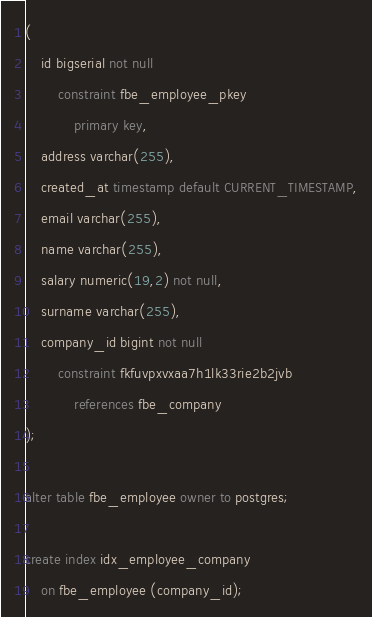<code> <loc_0><loc_0><loc_500><loc_500><_SQL_>(
	id bigserial not null
		constraint fbe_employee_pkey
			primary key,
	address varchar(255),
	created_at timestamp default CURRENT_TIMESTAMP,
	email varchar(255),
	name varchar(255),
	salary numeric(19,2) not null,
	surname varchar(255),
	company_id bigint not null
		constraint fkfuvpxvxaa7h1lk33rie2b2jvb
			references fbe_company
);

alter table fbe_employee owner to postgres;

create index idx_employee_company
	on fbe_employee (company_id);

</code> 